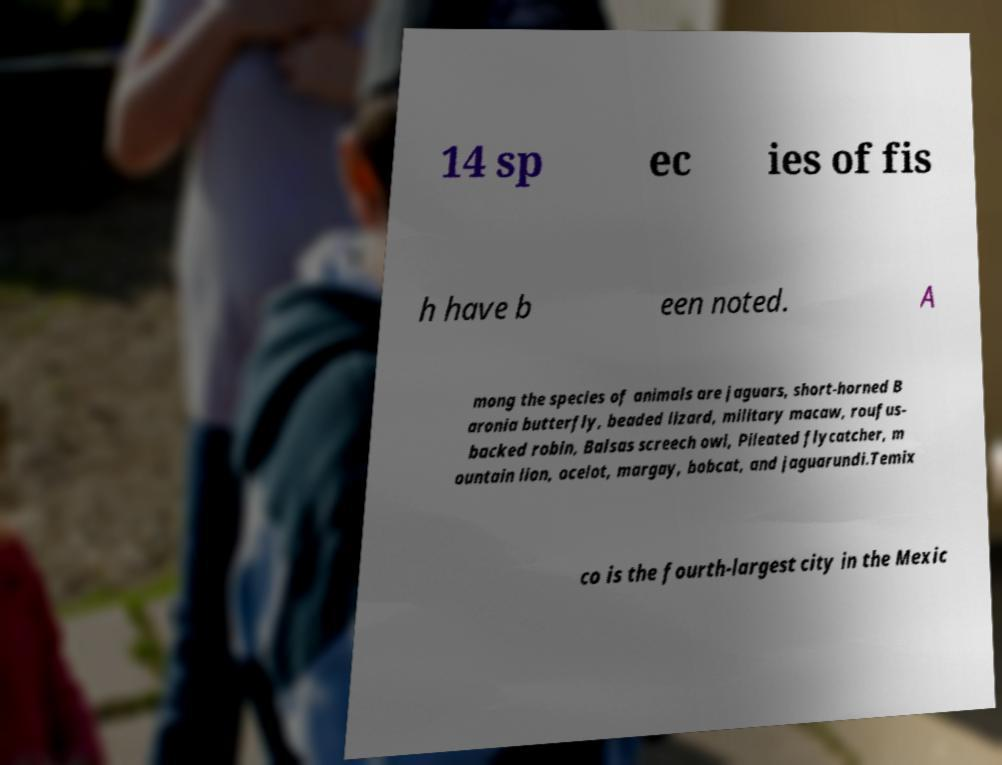There's text embedded in this image that I need extracted. Can you transcribe it verbatim? 14 sp ec ies of fis h have b een noted. A mong the species of animals are jaguars, short-horned B aronia butterfly, beaded lizard, military macaw, roufus- backed robin, Balsas screech owl, Pileated flycatcher, m ountain lion, ocelot, margay, bobcat, and jaguarundi.Temix co is the fourth-largest city in the Mexic 